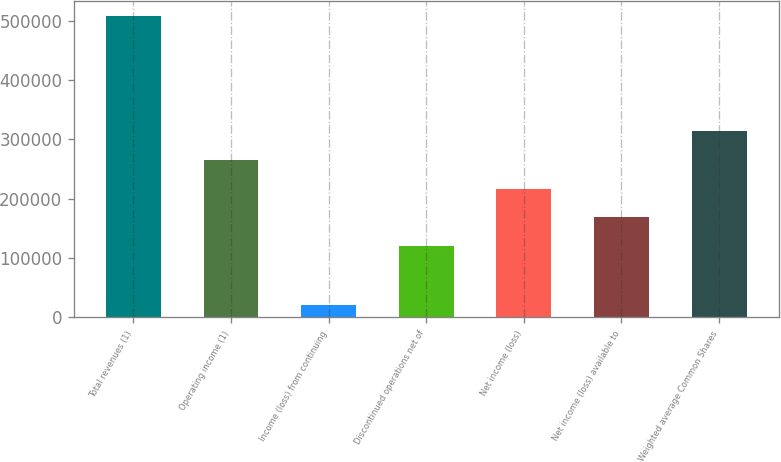Convert chart. <chart><loc_0><loc_0><loc_500><loc_500><bar_chart><fcel>Total revenues (1)<fcel>Operating income (1)<fcel>Income (loss) from continuing<fcel>Discontinued operations net of<fcel>Net income (loss)<fcel>Net income (loss) available to<fcel>Weighted average Common Shares<nl><fcel>507405<fcel>265869<fcel>20642<fcel>119840<fcel>217193<fcel>168516<fcel>314545<nl></chart> 